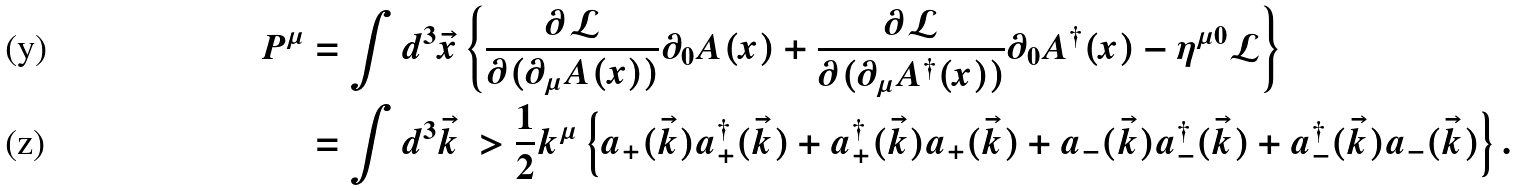Convert formula to latex. <formula><loc_0><loc_0><loc_500><loc_500>P ^ { \mu } & = \int d ^ { 3 } \vec { x } \left \{ \frac { \partial \mathcal { L } } { \partial ( \partial _ { \mu } A ( x ) ) } \partial _ { 0 } A ( x ) + \frac { \partial \mathcal { L } } { \partial ( \partial _ { \mu } A ^ { \dagger } ( x ) ) } \partial _ { 0 } A ^ { \dagger } ( x ) - \eta ^ { \mu 0 } \mathcal { L } \right \} \\ & = \int d ^ { 3 } \vec { k } \ > \frac { 1 } { 2 } k ^ { \mu } \left \{ a _ { + } ( \vec { k } ) a _ { + } ^ { \dagger } ( \vec { k } ) + a _ { + } ^ { \dagger } ( \vec { k } ) a _ { + } ( \vec { k } ) + a _ { - } ( \vec { k } ) a _ { - } ^ { \dagger } ( \vec { k } ) + a _ { - } ^ { \dagger } ( \vec { k } ) a _ { - } ( \vec { k } ) \right \} .</formula> 